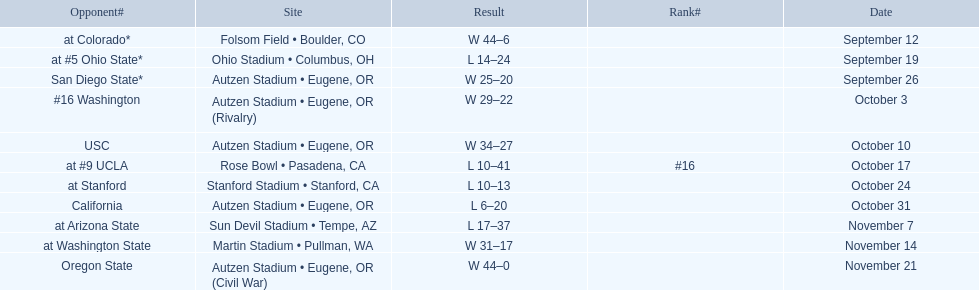Between september 26 and october 24, how many games were played in eugene, or? 3. 